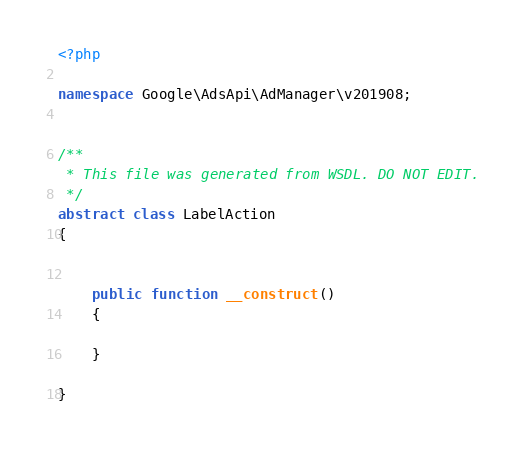Convert code to text. <code><loc_0><loc_0><loc_500><loc_500><_PHP_><?php

namespace Google\AdsApi\AdManager\v201908;


/**
 * This file was generated from WSDL. DO NOT EDIT.
 */
abstract class LabelAction
{

    
    public function __construct()
    {
    
    }

}
</code> 